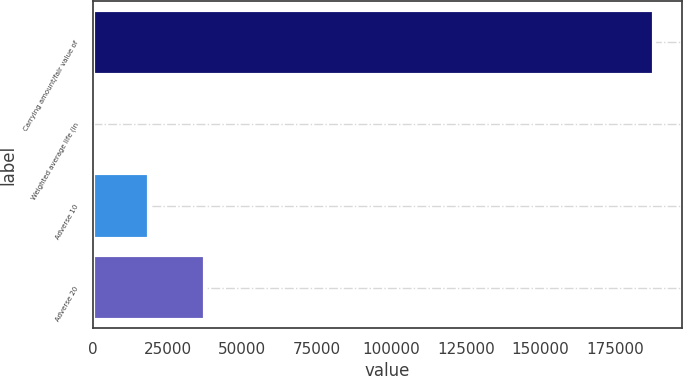<chart> <loc_0><loc_0><loc_500><loc_500><bar_chart><fcel>Carrying amount/fair value of<fcel>Weighted average life (in<fcel>Adverse 10<fcel>Adverse 20<nl><fcel>188014<fcel>1.9<fcel>18803.1<fcel>37604.3<nl></chart> 